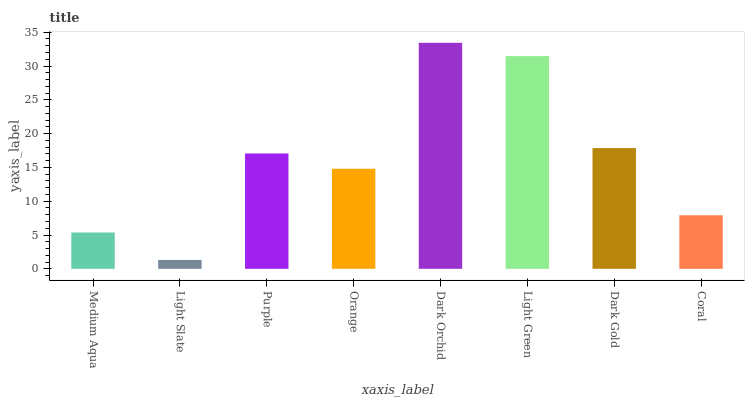Is Purple the minimum?
Answer yes or no. No. Is Purple the maximum?
Answer yes or no. No. Is Purple greater than Light Slate?
Answer yes or no. Yes. Is Light Slate less than Purple?
Answer yes or no. Yes. Is Light Slate greater than Purple?
Answer yes or no. No. Is Purple less than Light Slate?
Answer yes or no. No. Is Purple the high median?
Answer yes or no. Yes. Is Orange the low median?
Answer yes or no. Yes. Is Coral the high median?
Answer yes or no. No. Is Coral the low median?
Answer yes or no. No. 